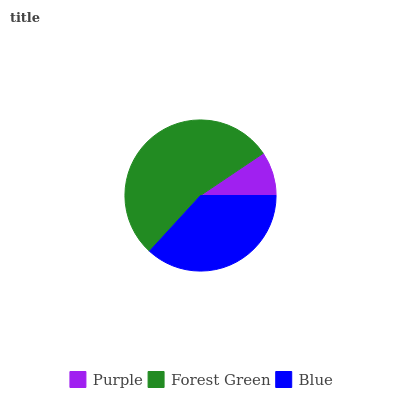Is Purple the minimum?
Answer yes or no. Yes. Is Forest Green the maximum?
Answer yes or no. Yes. Is Blue the minimum?
Answer yes or no. No. Is Blue the maximum?
Answer yes or no. No. Is Forest Green greater than Blue?
Answer yes or no. Yes. Is Blue less than Forest Green?
Answer yes or no. Yes. Is Blue greater than Forest Green?
Answer yes or no. No. Is Forest Green less than Blue?
Answer yes or no. No. Is Blue the high median?
Answer yes or no. Yes. Is Blue the low median?
Answer yes or no. Yes. Is Purple the high median?
Answer yes or no. No. Is Purple the low median?
Answer yes or no. No. 